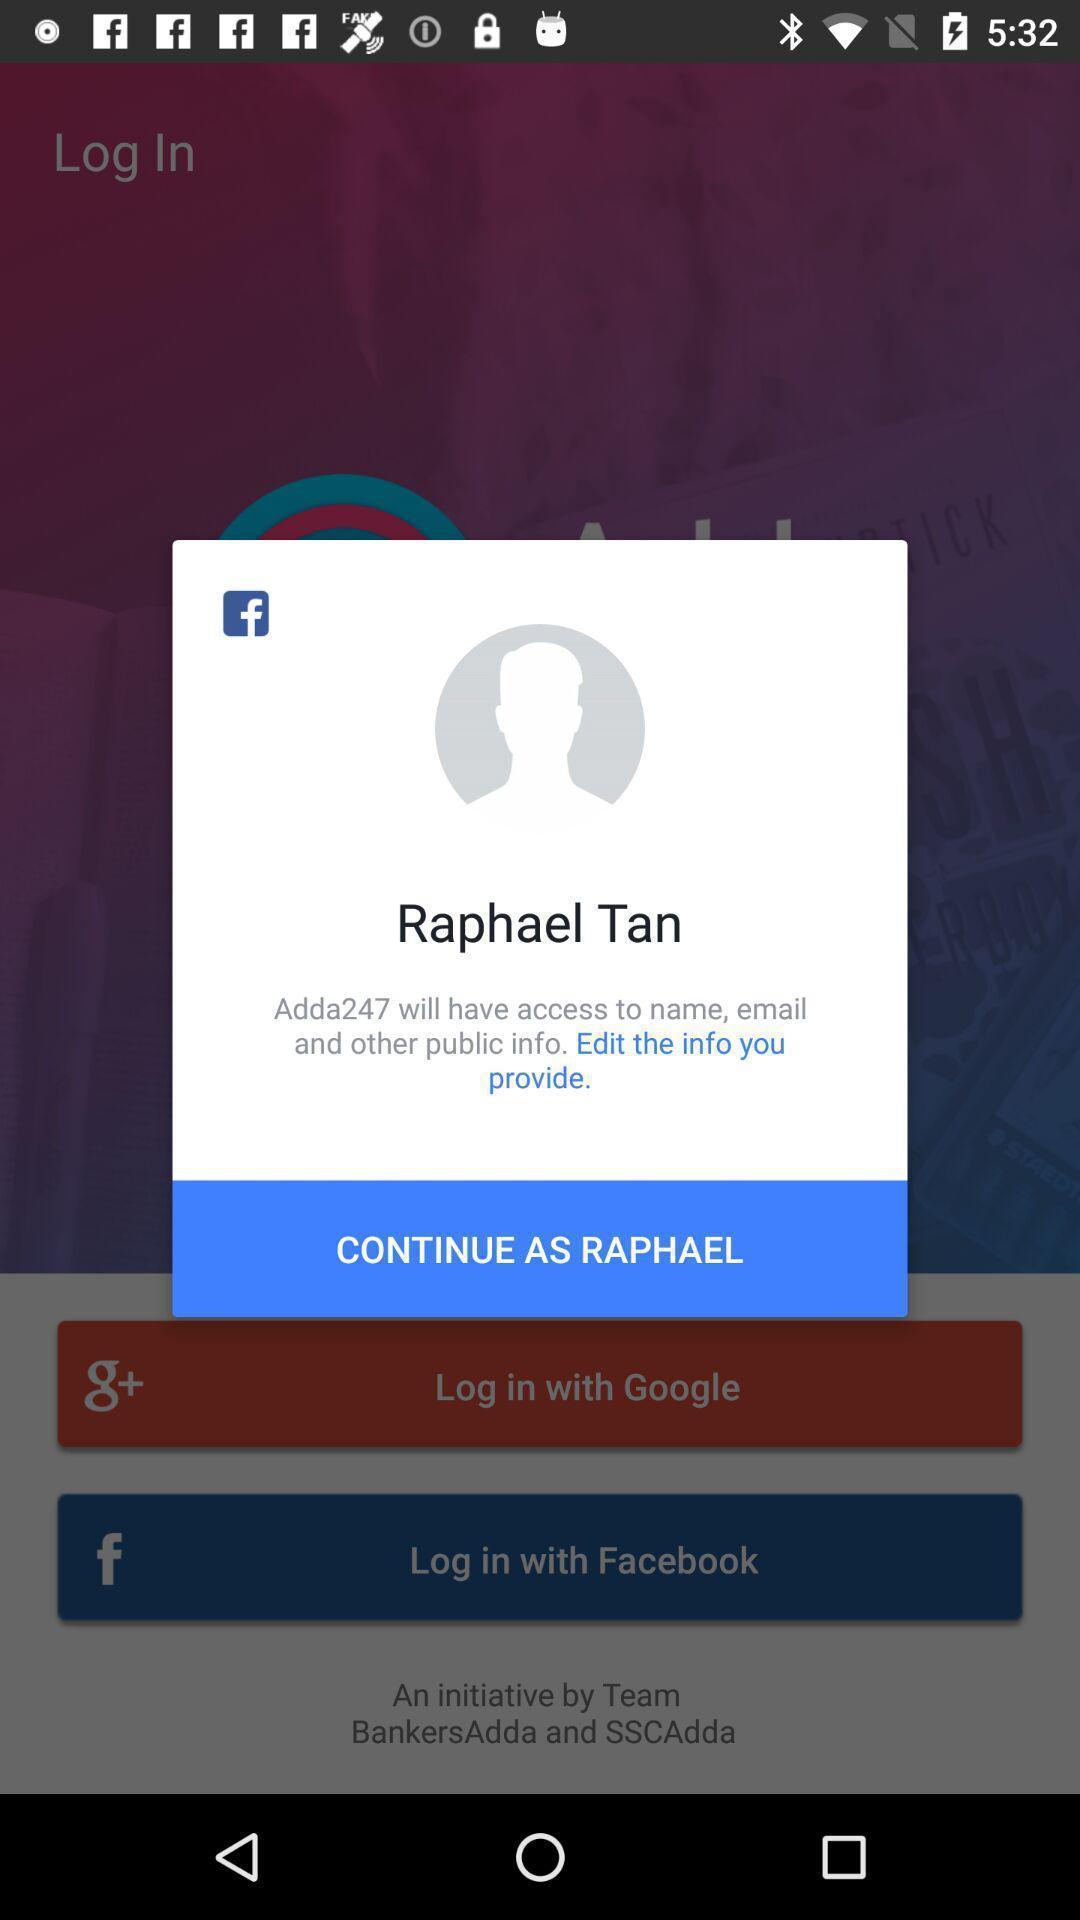Explain the elements present in this screenshot. Popup showing about profile to continue. 